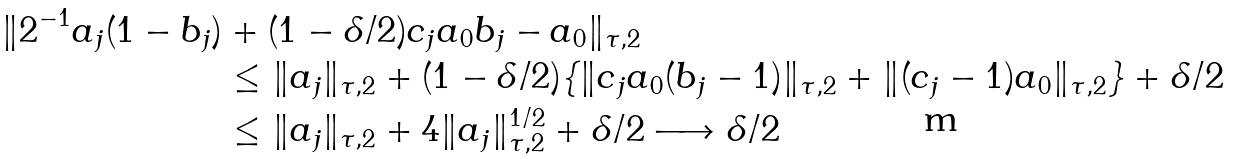Convert formula to latex. <formula><loc_0><loc_0><loc_500><loc_500>\| 2 ^ { - 1 } a _ { j } ( 1 - b _ { j } ) & + ( 1 - \delta / 2 ) c _ { j } a _ { 0 } b _ { j } - a _ { 0 } \| _ { \tau , 2 } \\ & \leq \| a _ { j } \| _ { \tau , 2 } + ( 1 - \delta / 2 ) \{ \| c _ { j } a _ { 0 } ( b _ { j } - 1 ) \| _ { \tau , 2 } + \| ( c _ { j } - 1 ) a _ { 0 } \| _ { \tau , 2 } \} + \delta / 2 \\ & \leq \| a _ { j } \| _ { \tau , 2 } + 4 \| a _ { j } \| _ { \tau , 2 } ^ { 1 / 2 } + \delta / 2 \longrightarrow \delta / 2</formula> 